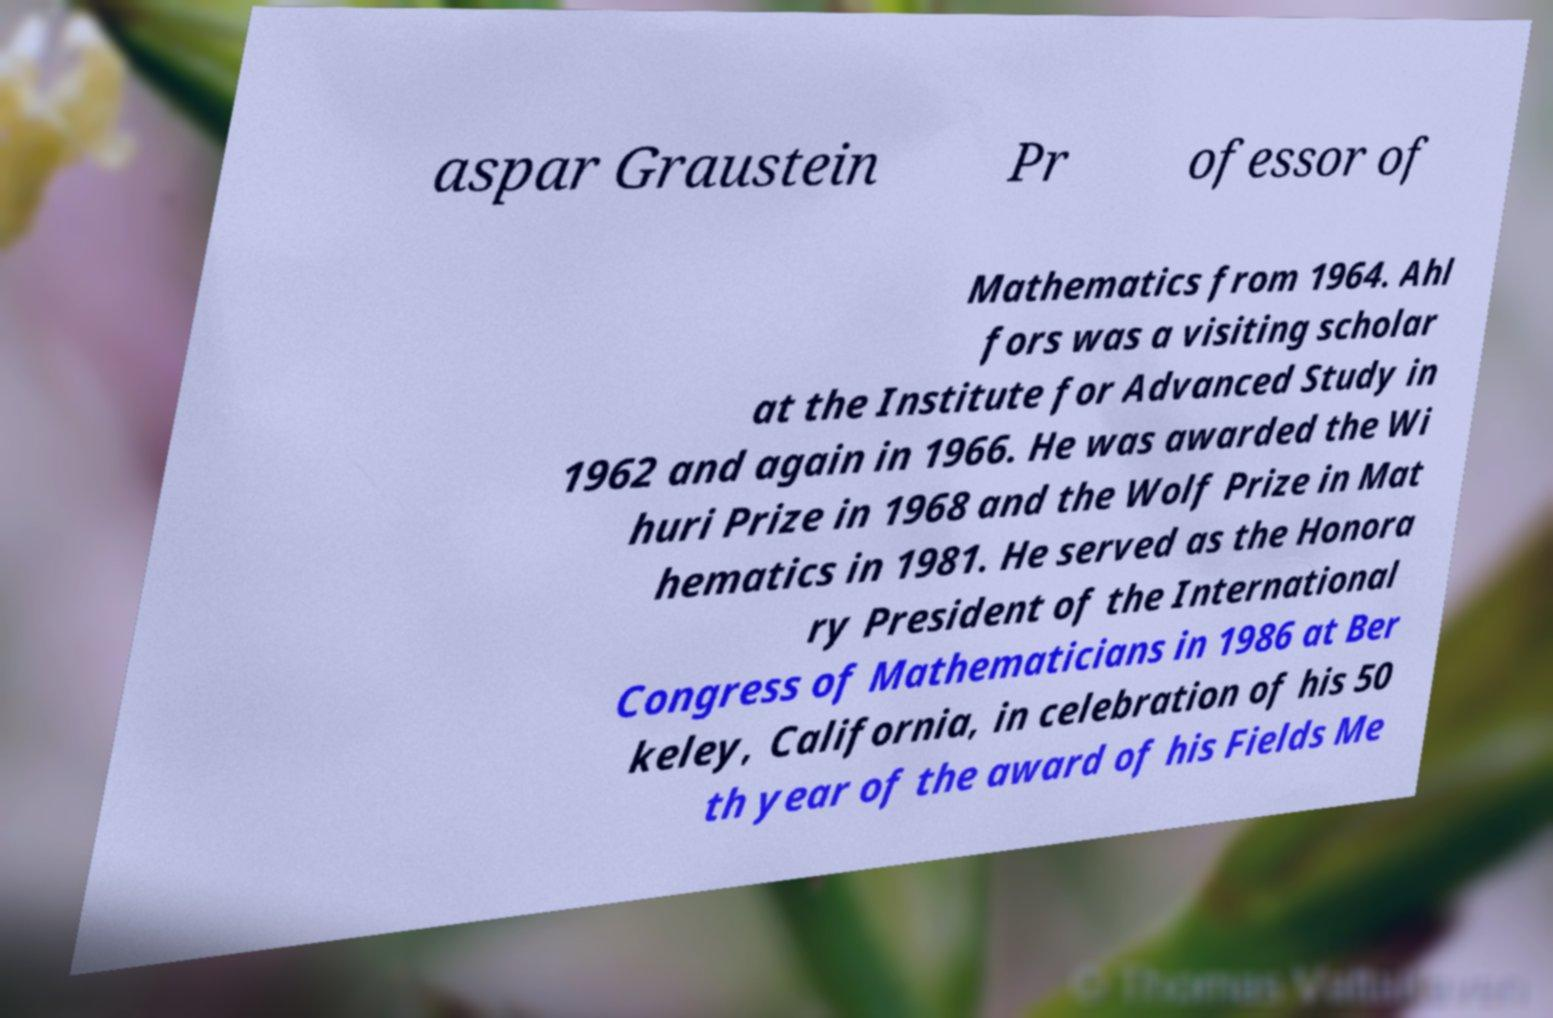I need the written content from this picture converted into text. Can you do that? aspar Graustein Pr ofessor of Mathematics from 1964. Ahl fors was a visiting scholar at the Institute for Advanced Study in 1962 and again in 1966. He was awarded the Wi huri Prize in 1968 and the Wolf Prize in Mat hematics in 1981. He served as the Honora ry President of the International Congress of Mathematicians in 1986 at Ber keley, California, in celebration of his 50 th year of the award of his Fields Me 